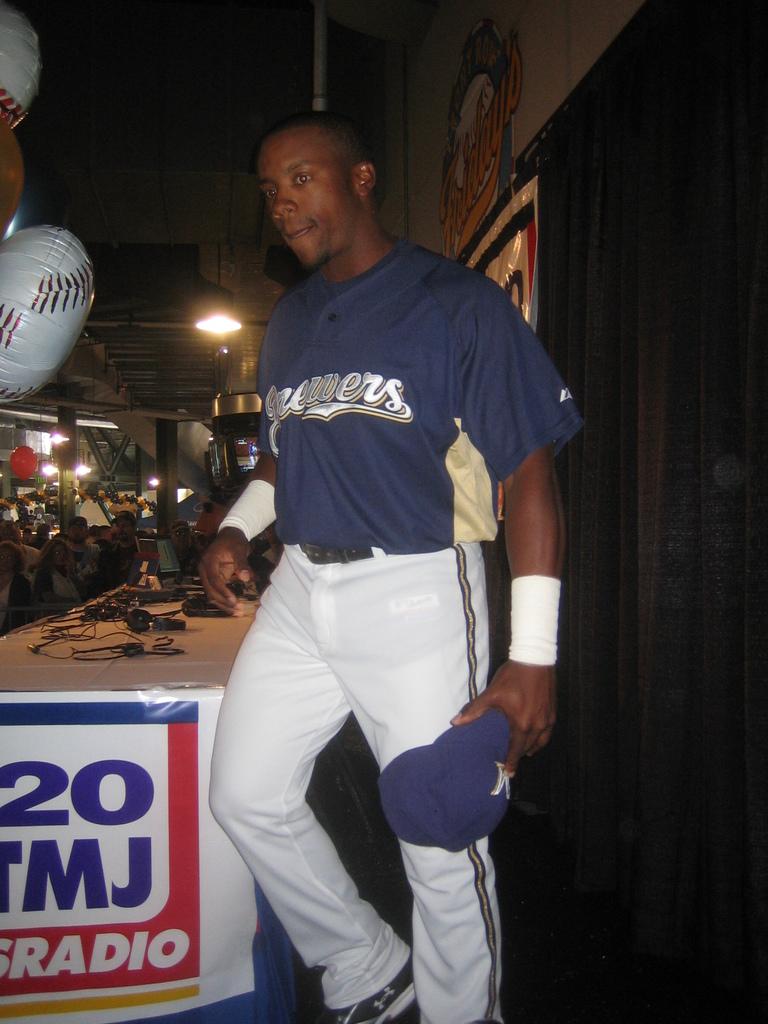What team does he play for?
Keep it short and to the point. Brewers. What color are the letters on jersey?
Your answer should be compact. White. 